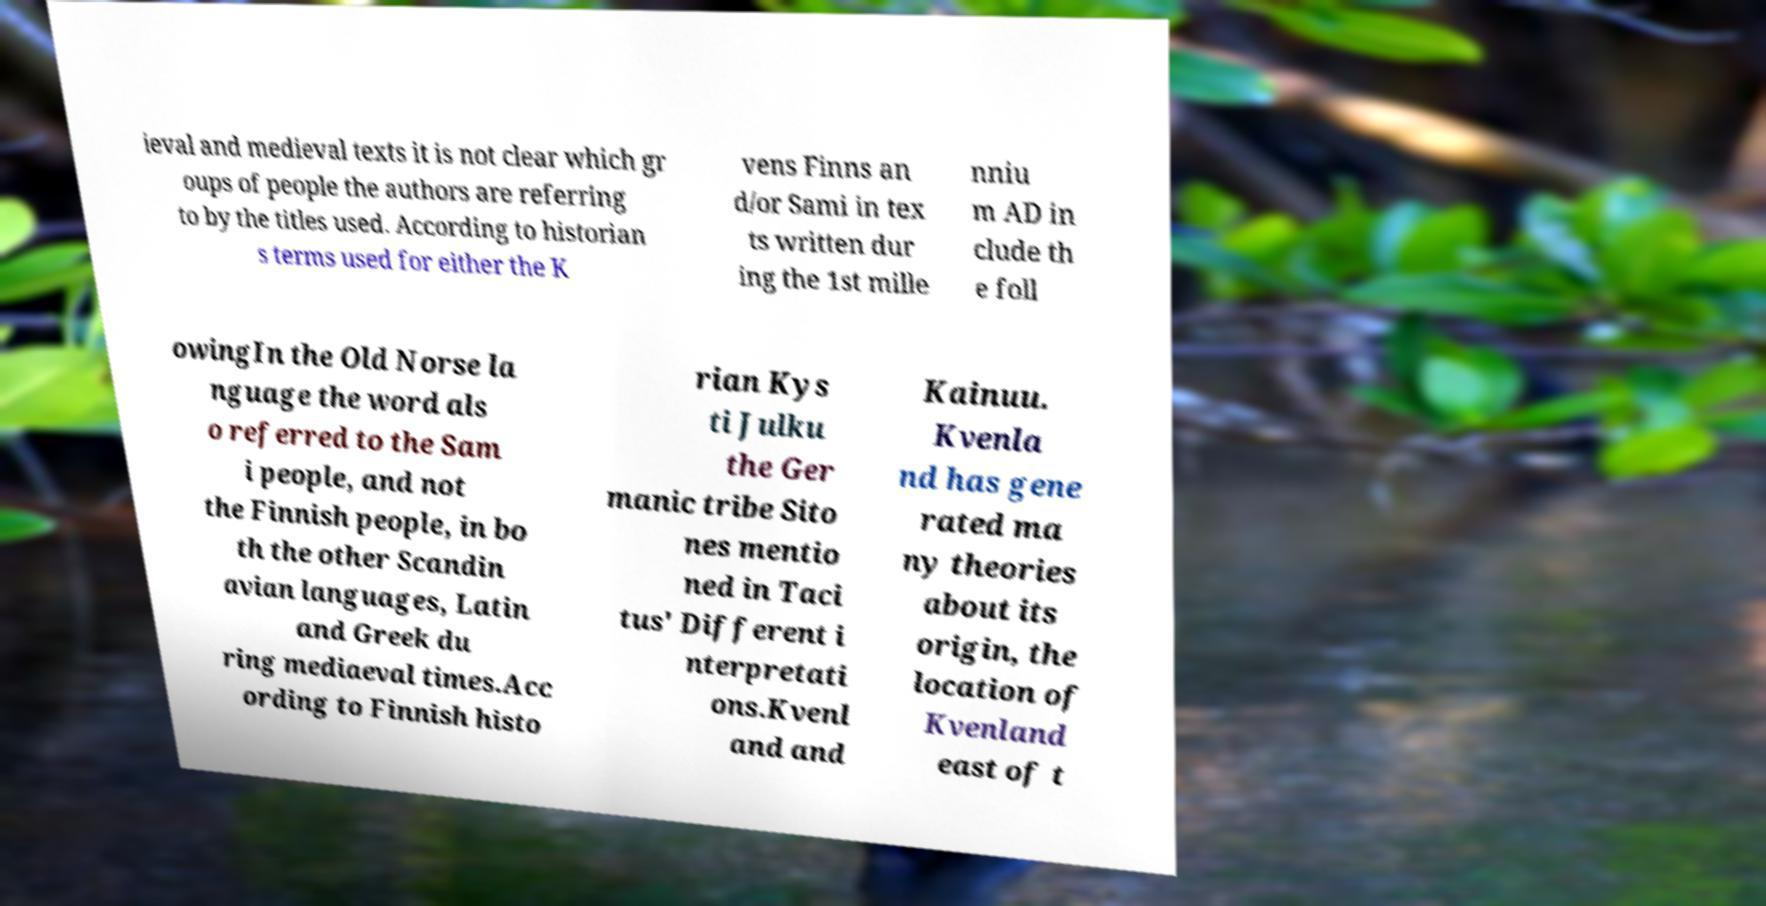Please read and relay the text visible in this image. What does it say? ieval and medieval texts it is not clear which gr oups of people the authors are referring to by the titles used. According to historian s terms used for either the K vens Finns an d/or Sami in tex ts written dur ing the 1st mille nniu m AD in clude th e foll owingIn the Old Norse la nguage the word als o referred to the Sam i people, and not the Finnish people, in bo th the other Scandin avian languages, Latin and Greek du ring mediaeval times.Acc ording to Finnish histo rian Kys ti Julku the Ger manic tribe Sito nes mentio ned in Taci tus' Different i nterpretati ons.Kvenl and and Kainuu. Kvenla nd has gene rated ma ny theories about its origin, the location of Kvenland east of t 